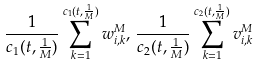Convert formula to latex. <formula><loc_0><loc_0><loc_500><loc_500>\frac { 1 } { c _ { 1 } ( t , \frac { 1 } { M } ) } \sum _ { k = 1 } ^ { c _ { 1 } ( t , \frac { 1 } { M } ) } { w } _ { i , k } ^ { M } , \, \frac { 1 } { c _ { 2 } ( t , \frac { 1 } { M } ) } \sum _ { k = 1 } ^ { c _ { 2 } ( t , \frac { 1 } { M } ) } { v } _ { i , k } ^ { M }</formula> 